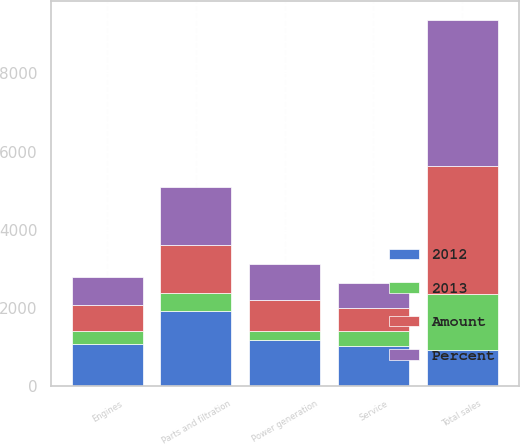Convert chart to OTSL. <chart><loc_0><loc_0><loc_500><loc_500><stacked_bar_chart><ecel><fcel>Parts and filtration<fcel>Power generation<fcel>Engines<fcel>Service<fcel>Total sales<nl><fcel>2012<fcel>1924<fcel>1163<fcel>1061<fcel>1026<fcel>931<nl><fcel>Percent<fcel>1465<fcel>931<fcel>713<fcel>640<fcel>3749<nl><fcel>Amount<fcel>1235<fcel>807<fcel>665<fcel>570<fcel>3277<nl><fcel>2013<fcel>459<fcel>232<fcel>348<fcel>386<fcel>1425<nl></chart> 